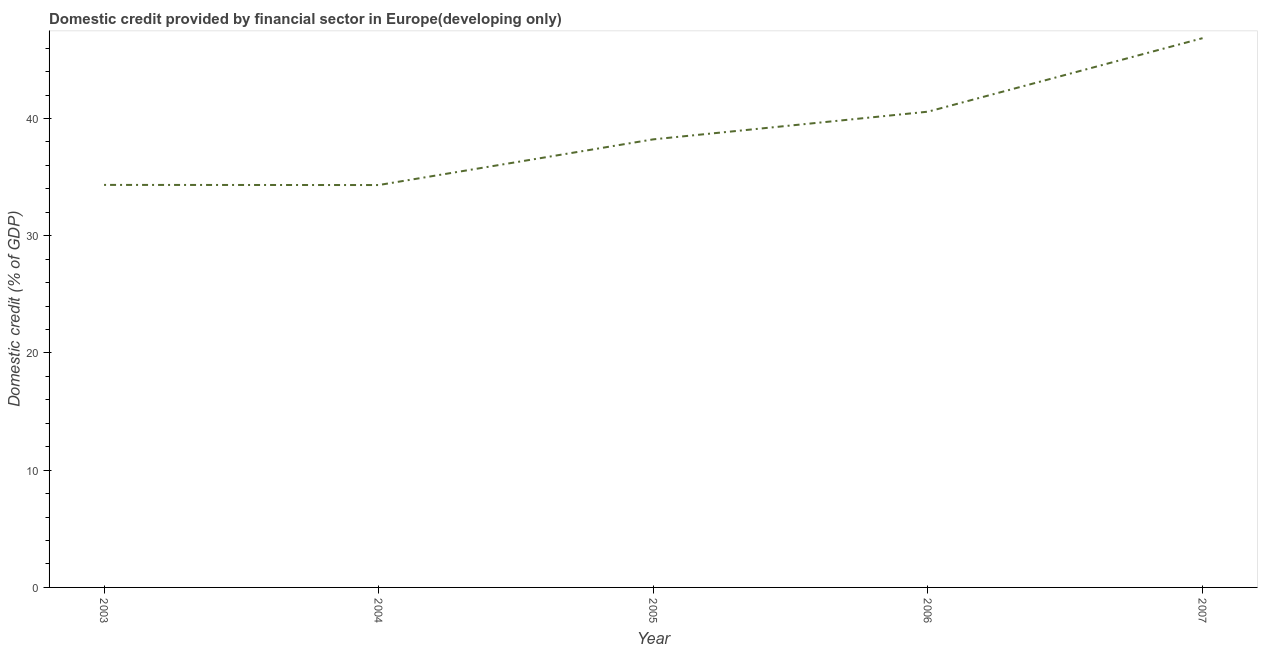What is the domestic credit provided by financial sector in 2005?
Offer a very short reply. 38.22. Across all years, what is the maximum domestic credit provided by financial sector?
Make the answer very short. 46.85. Across all years, what is the minimum domestic credit provided by financial sector?
Give a very brief answer. 34.32. In which year was the domestic credit provided by financial sector maximum?
Make the answer very short. 2007. In which year was the domestic credit provided by financial sector minimum?
Your answer should be compact. 2004. What is the sum of the domestic credit provided by financial sector?
Provide a short and direct response. 194.29. What is the difference between the domestic credit provided by financial sector in 2006 and 2007?
Offer a very short reply. -6.27. What is the average domestic credit provided by financial sector per year?
Your answer should be very brief. 38.86. What is the median domestic credit provided by financial sector?
Your answer should be compact. 38.22. Do a majority of the years between 2006 and 2007 (inclusive) have domestic credit provided by financial sector greater than 40 %?
Provide a short and direct response. Yes. What is the ratio of the domestic credit provided by financial sector in 2005 to that in 2006?
Your answer should be compact. 0.94. Is the domestic credit provided by financial sector in 2005 less than that in 2006?
Give a very brief answer. Yes. Is the difference between the domestic credit provided by financial sector in 2006 and 2007 greater than the difference between any two years?
Make the answer very short. No. What is the difference between the highest and the second highest domestic credit provided by financial sector?
Provide a short and direct response. 6.27. What is the difference between the highest and the lowest domestic credit provided by financial sector?
Give a very brief answer. 12.53. In how many years, is the domestic credit provided by financial sector greater than the average domestic credit provided by financial sector taken over all years?
Your answer should be very brief. 2. What is the title of the graph?
Your answer should be compact. Domestic credit provided by financial sector in Europe(developing only). What is the label or title of the X-axis?
Provide a short and direct response. Year. What is the label or title of the Y-axis?
Your response must be concise. Domestic credit (% of GDP). What is the Domestic credit (% of GDP) in 2003?
Provide a short and direct response. 34.33. What is the Domestic credit (% of GDP) of 2004?
Provide a short and direct response. 34.32. What is the Domestic credit (% of GDP) in 2005?
Provide a short and direct response. 38.22. What is the Domestic credit (% of GDP) in 2006?
Provide a succinct answer. 40.58. What is the Domestic credit (% of GDP) in 2007?
Provide a succinct answer. 46.85. What is the difference between the Domestic credit (% of GDP) in 2003 and 2004?
Give a very brief answer. 0.01. What is the difference between the Domestic credit (% of GDP) in 2003 and 2005?
Give a very brief answer. -3.89. What is the difference between the Domestic credit (% of GDP) in 2003 and 2006?
Provide a succinct answer. -6.25. What is the difference between the Domestic credit (% of GDP) in 2003 and 2007?
Your response must be concise. -12.52. What is the difference between the Domestic credit (% of GDP) in 2004 and 2005?
Make the answer very short. -3.9. What is the difference between the Domestic credit (% of GDP) in 2004 and 2006?
Your answer should be very brief. -6.26. What is the difference between the Domestic credit (% of GDP) in 2004 and 2007?
Make the answer very short. -12.53. What is the difference between the Domestic credit (% of GDP) in 2005 and 2006?
Ensure brevity in your answer.  -2.36. What is the difference between the Domestic credit (% of GDP) in 2005 and 2007?
Provide a short and direct response. -8.63. What is the difference between the Domestic credit (% of GDP) in 2006 and 2007?
Ensure brevity in your answer.  -6.27. What is the ratio of the Domestic credit (% of GDP) in 2003 to that in 2004?
Your answer should be very brief. 1. What is the ratio of the Domestic credit (% of GDP) in 2003 to that in 2005?
Keep it short and to the point. 0.9. What is the ratio of the Domestic credit (% of GDP) in 2003 to that in 2006?
Provide a short and direct response. 0.85. What is the ratio of the Domestic credit (% of GDP) in 2003 to that in 2007?
Your answer should be compact. 0.73. What is the ratio of the Domestic credit (% of GDP) in 2004 to that in 2005?
Provide a succinct answer. 0.9. What is the ratio of the Domestic credit (% of GDP) in 2004 to that in 2006?
Provide a short and direct response. 0.85. What is the ratio of the Domestic credit (% of GDP) in 2004 to that in 2007?
Your answer should be compact. 0.73. What is the ratio of the Domestic credit (% of GDP) in 2005 to that in 2006?
Offer a very short reply. 0.94. What is the ratio of the Domestic credit (% of GDP) in 2005 to that in 2007?
Make the answer very short. 0.82. What is the ratio of the Domestic credit (% of GDP) in 2006 to that in 2007?
Ensure brevity in your answer.  0.87. 